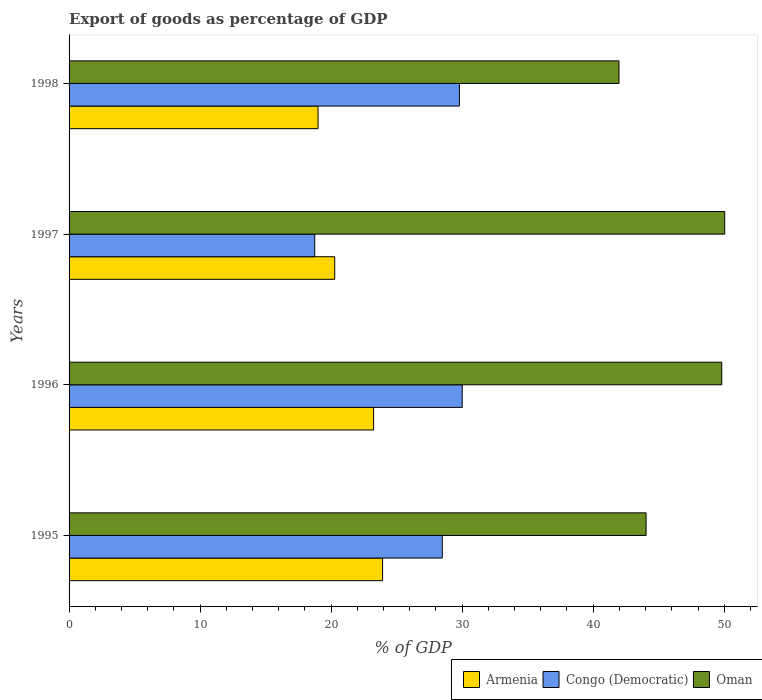How many different coloured bars are there?
Keep it short and to the point. 3. What is the label of the 2nd group of bars from the top?
Offer a very short reply. 1997. What is the export of goods as percentage of GDP in Oman in 1996?
Offer a very short reply. 49.81. Across all years, what is the maximum export of goods as percentage of GDP in Armenia?
Provide a succinct answer. 23.93. Across all years, what is the minimum export of goods as percentage of GDP in Congo (Democratic)?
Give a very brief answer. 18.75. In which year was the export of goods as percentage of GDP in Armenia maximum?
Your answer should be compact. 1995. What is the total export of goods as percentage of GDP in Oman in the graph?
Your answer should be very brief. 185.85. What is the difference between the export of goods as percentage of GDP in Oman in 1995 and that in 1996?
Your answer should be very brief. -5.77. What is the difference between the export of goods as percentage of GDP in Armenia in 1996 and the export of goods as percentage of GDP in Congo (Democratic) in 1997?
Ensure brevity in your answer.  4.49. What is the average export of goods as percentage of GDP in Oman per year?
Provide a succinct answer. 46.46. In the year 1997, what is the difference between the export of goods as percentage of GDP in Armenia and export of goods as percentage of GDP in Congo (Democratic)?
Provide a short and direct response. 1.52. What is the ratio of the export of goods as percentage of GDP in Armenia in 1997 to that in 1998?
Your answer should be compact. 1.07. Is the export of goods as percentage of GDP in Congo (Democratic) in 1995 less than that in 1997?
Provide a short and direct response. No. What is the difference between the highest and the second highest export of goods as percentage of GDP in Oman?
Give a very brief answer. 0.23. What is the difference between the highest and the lowest export of goods as percentage of GDP in Congo (Democratic)?
Provide a short and direct response. 11.25. What does the 1st bar from the top in 1998 represents?
Keep it short and to the point. Oman. What does the 3rd bar from the bottom in 1997 represents?
Offer a terse response. Oman. What is the difference between two consecutive major ticks on the X-axis?
Make the answer very short. 10. Are the values on the major ticks of X-axis written in scientific E-notation?
Offer a terse response. No. Does the graph contain grids?
Keep it short and to the point. No. How are the legend labels stacked?
Offer a very short reply. Horizontal. What is the title of the graph?
Keep it short and to the point. Export of goods as percentage of GDP. Does "Turkmenistan" appear as one of the legend labels in the graph?
Offer a very short reply. No. What is the label or title of the X-axis?
Your answer should be compact. % of GDP. What is the % of GDP in Armenia in 1995?
Your response must be concise. 23.93. What is the % of GDP of Congo (Democratic) in 1995?
Your answer should be compact. 28.48. What is the % of GDP in Oman in 1995?
Your answer should be compact. 44.04. What is the % of GDP of Armenia in 1996?
Offer a terse response. 23.24. What is the % of GDP in Congo (Democratic) in 1996?
Your response must be concise. 30. What is the % of GDP in Oman in 1996?
Offer a very short reply. 49.81. What is the % of GDP in Armenia in 1997?
Your answer should be compact. 20.27. What is the % of GDP of Congo (Democratic) in 1997?
Your answer should be very brief. 18.75. What is the % of GDP of Oman in 1997?
Your answer should be compact. 50.04. What is the % of GDP of Armenia in 1998?
Ensure brevity in your answer.  19. What is the % of GDP in Congo (Democratic) in 1998?
Your response must be concise. 29.79. What is the % of GDP in Oman in 1998?
Provide a short and direct response. 41.97. Across all years, what is the maximum % of GDP in Armenia?
Offer a very short reply. 23.93. Across all years, what is the maximum % of GDP of Congo (Democratic)?
Your response must be concise. 30. Across all years, what is the maximum % of GDP in Oman?
Keep it short and to the point. 50.04. Across all years, what is the minimum % of GDP of Armenia?
Your answer should be compact. 19. Across all years, what is the minimum % of GDP of Congo (Democratic)?
Your answer should be very brief. 18.75. Across all years, what is the minimum % of GDP of Oman?
Your response must be concise. 41.97. What is the total % of GDP in Armenia in the graph?
Offer a very short reply. 86.44. What is the total % of GDP of Congo (Democratic) in the graph?
Ensure brevity in your answer.  107.03. What is the total % of GDP in Oman in the graph?
Your answer should be compact. 185.85. What is the difference between the % of GDP of Armenia in 1995 and that in 1996?
Give a very brief answer. 0.69. What is the difference between the % of GDP in Congo (Democratic) in 1995 and that in 1996?
Provide a succinct answer. -1.52. What is the difference between the % of GDP in Oman in 1995 and that in 1996?
Your answer should be compact. -5.77. What is the difference between the % of GDP of Armenia in 1995 and that in 1997?
Your response must be concise. 3.65. What is the difference between the % of GDP in Congo (Democratic) in 1995 and that in 1997?
Offer a terse response. 9.73. What is the difference between the % of GDP of Oman in 1995 and that in 1997?
Ensure brevity in your answer.  -6. What is the difference between the % of GDP of Armenia in 1995 and that in 1998?
Ensure brevity in your answer.  4.92. What is the difference between the % of GDP in Congo (Democratic) in 1995 and that in 1998?
Provide a succinct answer. -1.31. What is the difference between the % of GDP of Oman in 1995 and that in 1998?
Your answer should be very brief. 2.07. What is the difference between the % of GDP of Armenia in 1996 and that in 1997?
Give a very brief answer. 2.97. What is the difference between the % of GDP in Congo (Democratic) in 1996 and that in 1997?
Offer a very short reply. 11.25. What is the difference between the % of GDP in Oman in 1996 and that in 1997?
Your answer should be very brief. -0.23. What is the difference between the % of GDP of Armenia in 1996 and that in 1998?
Offer a terse response. 4.24. What is the difference between the % of GDP of Congo (Democratic) in 1996 and that in 1998?
Offer a terse response. 0.21. What is the difference between the % of GDP of Oman in 1996 and that in 1998?
Provide a succinct answer. 7.84. What is the difference between the % of GDP of Armenia in 1997 and that in 1998?
Ensure brevity in your answer.  1.27. What is the difference between the % of GDP in Congo (Democratic) in 1997 and that in 1998?
Keep it short and to the point. -11.04. What is the difference between the % of GDP of Oman in 1997 and that in 1998?
Make the answer very short. 8.07. What is the difference between the % of GDP of Armenia in 1995 and the % of GDP of Congo (Democratic) in 1996?
Offer a very short reply. -6.07. What is the difference between the % of GDP of Armenia in 1995 and the % of GDP of Oman in 1996?
Provide a short and direct response. -25.88. What is the difference between the % of GDP of Congo (Democratic) in 1995 and the % of GDP of Oman in 1996?
Offer a very short reply. -21.33. What is the difference between the % of GDP in Armenia in 1995 and the % of GDP in Congo (Democratic) in 1997?
Provide a short and direct response. 5.18. What is the difference between the % of GDP of Armenia in 1995 and the % of GDP of Oman in 1997?
Make the answer very short. -26.11. What is the difference between the % of GDP of Congo (Democratic) in 1995 and the % of GDP of Oman in 1997?
Give a very brief answer. -21.55. What is the difference between the % of GDP in Armenia in 1995 and the % of GDP in Congo (Democratic) in 1998?
Give a very brief answer. -5.86. What is the difference between the % of GDP in Armenia in 1995 and the % of GDP in Oman in 1998?
Provide a succinct answer. -18.04. What is the difference between the % of GDP in Congo (Democratic) in 1995 and the % of GDP in Oman in 1998?
Provide a short and direct response. -13.49. What is the difference between the % of GDP of Armenia in 1996 and the % of GDP of Congo (Democratic) in 1997?
Provide a succinct answer. 4.49. What is the difference between the % of GDP of Armenia in 1996 and the % of GDP of Oman in 1997?
Offer a very short reply. -26.8. What is the difference between the % of GDP in Congo (Democratic) in 1996 and the % of GDP in Oman in 1997?
Keep it short and to the point. -20.03. What is the difference between the % of GDP in Armenia in 1996 and the % of GDP in Congo (Democratic) in 1998?
Keep it short and to the point. -6.55. What is the difference between the % of GDP of Armenia in 1996 and the % of GDP of Oman in 1998?
Your response must be concise. -18.73. What is the difference between the % of GDP of Congo (Democratic) in 1996 and the % of GDP of Oman in 1998?
Provide a short and direct response. -11.97. What is the difference between the % of GDP of Armenia in 1997 and the % of GDP of Congo (Democratic) in 1998?
Make the answer very short. -9.52. What is the difference between the % of GDP in Armenia in 1997 and the % of GDP in Oman in 1998?
Your answer should be compact. -21.7. What is the difference between the % of GDP of Congo (Democratic) in 1997 and the % of GDP of Oman in 1998?
Offer a very short reply. -23.22. What is the average % of GDP in Armenia per year?
Your answer should be very brief. 21.61. What is the average % of GDP in Congo (Democratic) per year?
Give a very brief answer. 26.76. What is the average % of GDP in Oman per year?
Offer a terse response. 46.46. In the year 1995, what is the difference between the % of GDP of Armenia and % of GDP of Congo (Democratic)?
Ensure brevity in your answer.  -4.55. In the year 1995, what is the difference between the % of GDP in Armenia and % of GDP in Oman?
Offer a very short reply. -20.11. In the year 1995, what is the difference between the % of GDP in Congo (Democratic) and % of GDP in Oman?
Make the answer very short. -15.55. In the year 1996, what is the difference between the % of GDP in Armenia and % of GDP in Congo (Democratic)?
Your answer should be very brief. -6.76. In the year 1996, what is the difference between the % of GDP of Armenia and % of GDP of Oman?
Keep it short and to the point. -26.57. In the year 1996, what is the difference between the % of GDP of Congo (Democratic) and % of GDP of Oman?
Your answer should be very brief. -19.81. In the year 1997, what is the difference between the % of GDP in Armenia and % of GDP in Congo (Democratic)?
Provide a succinct answer. 1.52. In the year 1997, what is the difference between the % of GDP of Armenia and % of GDP of Oman?
Offer a very short reply. -29.76. In the year 1997, what is the difference between the % of GDP of Congo (Democratic) and % of GDP of Oman?
Your answer should be compact. -31.29. In the year 1998, what is the difference between the % of GDP in Armenia and % of GDP in Congo (Democratic)?
Offer a very short reply. -10.79. In the year 1998, what is the difference between the % of GDP in Armenia and % of GDP in Oman?
Give a very brief answer. -22.97. In the year 1998, what is the difference between the % of GDP in Congo (Democratic) and % of GDP in Oman?
Offer a very short reply. -12.18. What is the ratio of the % of GDP of Armenia in 1995 to that in 1996?
Your response must be concise. 1.03. What is the ratio of the % of GDP of Congo (Democratic) in 1995 to that in 1996?
Provide a short and direct response. 0.95. What is the ratio of the % of GDP in Oman in 1995 to that in 1996?
Your answer should be very brief. 0.88. What is the ratio of the % of GDP of Armenia in 1995 to that in 1997?
Your response must be concise. 1.18. What is the ratio of the % of GDP in Congo (Democratic) in 1995 to that in 1997?
Provide a succinct answer. 1.52. What is the ratio of the % of GDP in Oman in 1995 to that in 1997?
Provide a succinct answer. 0.88. What is the ratio of the % of GDP of Armenia in 1995 to that in 1998?
Your response must be concise. 1.26. What is the ratio of the % of GDP in Congo (Democratic) in 1995 to that in 1998?
Your response must be concise. 0.96. What is the ratio of the % of GDP in Oman in 1995 to that in 1998?
Offer a very short reply. 1.05. What is the ratio of the % of GDP of Armenia in 1996 to that in 1997?
Provide a succinct answer. 1.15. What is the ratio of the % of GDP in Congo (Democratic) in 1996 to that in 1997?
Make the answer very short. 1.6. What is the ratio of the % of GDP in Armenia in 1996 to that in 1998?
Your answer should be compact. 1.22. What is the ratio of the % of GDP in Congo (Democratic) in 1996 to that in 1998?
Give a very brief answer. 1.01. What is the ratio of the % of GDP in Oman in 1996 to that in 1998?
Keep it short and to the point. 1.19. What is the ratio of the % of GDP in Armenia in 1997 to that in 1998?
Make the answer very short. 1.07. What is the ratio of the % of GDP in Congo (Democratic) in 1997 to that in 1998?
Your answer should be very brief. 0.63. What is the ratio of the % of GDP in Oman in 1997 to that in 1998?
Provide a succinct answer. 1.19. What is the difference between the highest and the second highest % of GDP of Armenia?
Your response must be concise. 0.69. What is the difference between the highest and the second highest % of GDP of Congo (Democratic)?
Keep it short and to the point. 0.21. What is the difference between the highest and the second highest % of GDP of Oman?
Keep it short and to the point. 0.23. What is the difference between the highest and the lowest % of GDP in Armenia?
Provide a short and direct response. 4.92. What is the difference between the highest and the lowest % of GDP of Congo (Democratic)?
Your response must be concise. 11.25. What is the difference between the highest and the lowest % of GDP in Oman?
Provide a short and direct response. 8.07. 